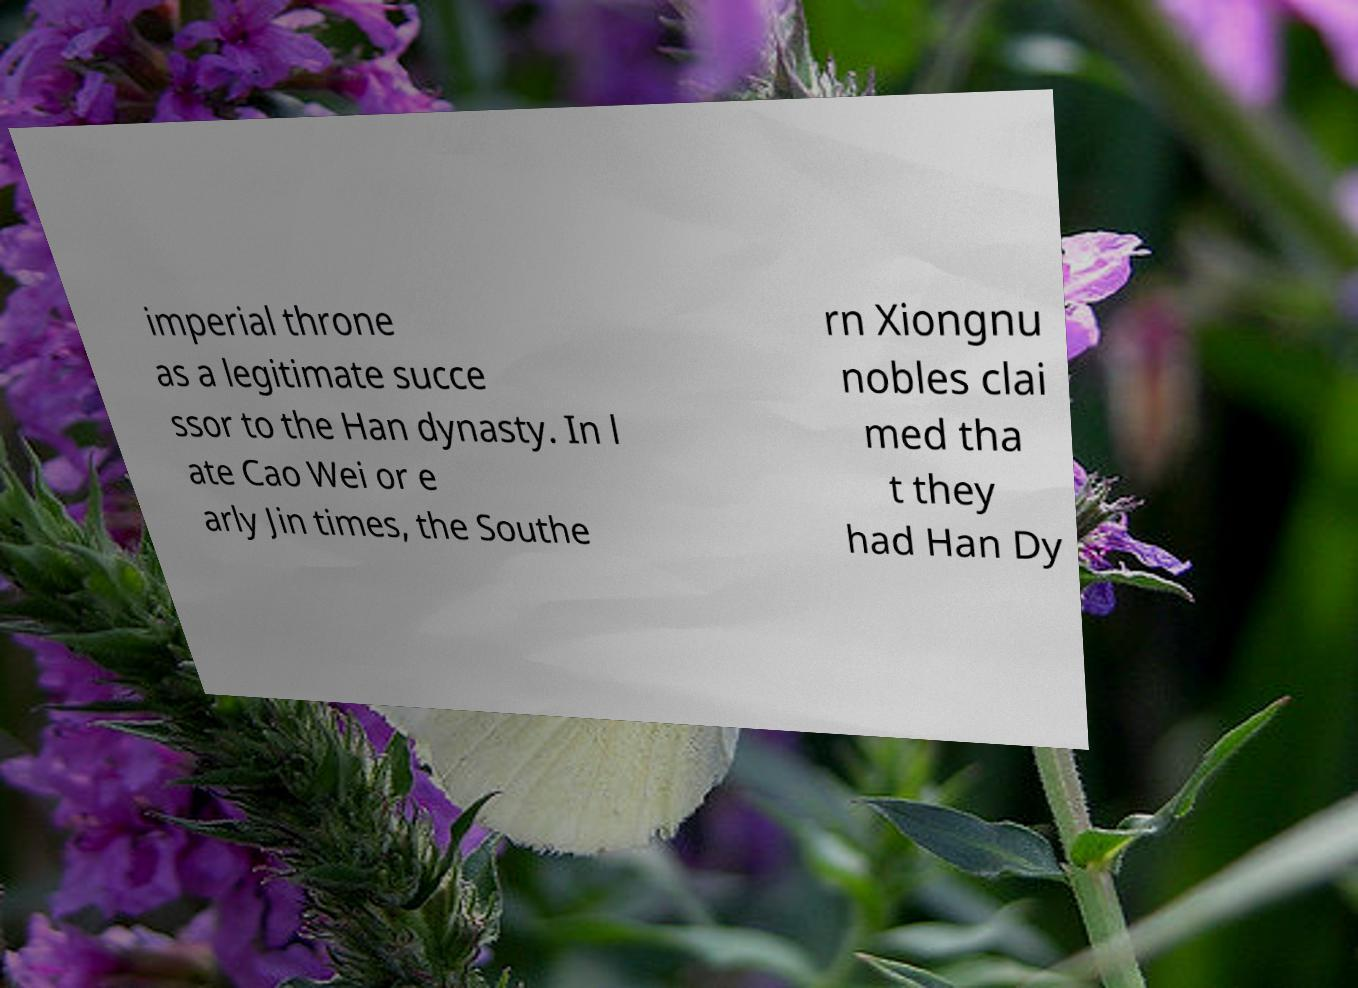Please identify and transcribe the text found in this image. imperial throne as a legitimate succe ssor to the Han dynasty. In l ate Cao Wei or e arly Jin times, the Southe rn Xiongnu nobles clai med tha t they had Han Dy 